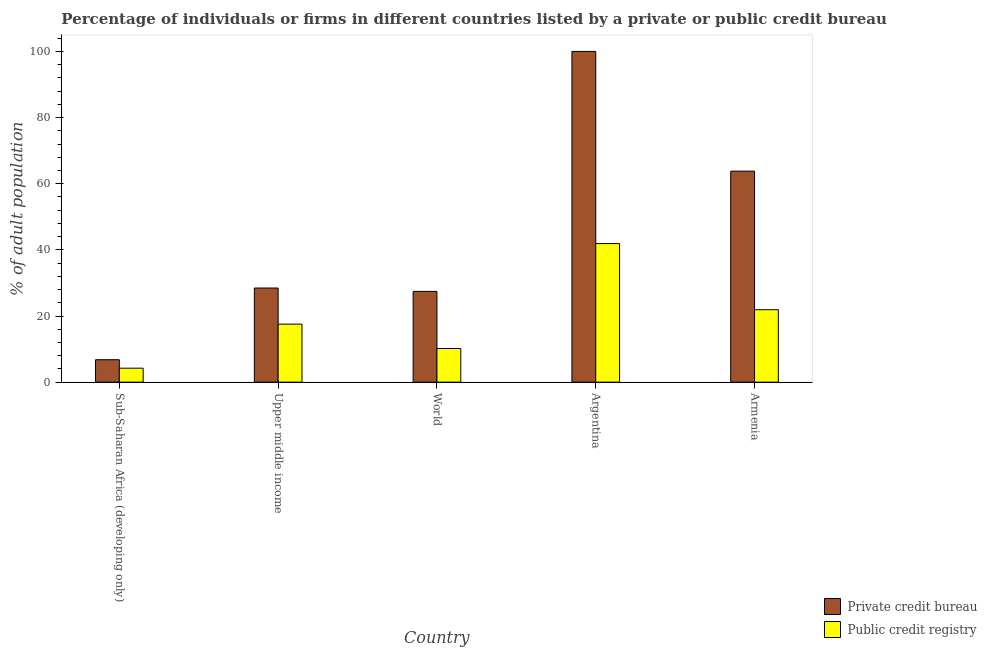How many groups of bars are there?
Provide a short and direct response. 5. Are the number of bars on each tick of the X-axis equal?
Offer a very short reply. Yes. How many bars are there on the 3rd tick from the left?
Make the answer very short. 2. What is the label of the 5th group of bars from the left?
Offer a very short reply. Armenia. In how many cases, is the number of bars for a given country not equal to the number of legend labels?
Keep it short and to the point. 0. What is the percentage of firms listed by private credit bureau in Argentina?
Make the answer very short. 100. Across all countries, what is the maximum percentage of firms listed by private credit bureau?
Give a very brief answer. 100. Across all countries, what is the minimum percentage of firms listed by public credit bureau?
Offer a very short reply. 4.22. In which country was the percentage of firms listed by public credit bureau maximum?
Keep it short and to the point. Argentina. In which country was the percentage of firms listed by public credit bureau minimum?
Provide a short and direct response. Sub-Saharan Africa (developing only). What is the total percentage of firms listed by private credit bureau in the graph?
Your response must be concise. 226.48. What is the difference between the percentage of firms listed by private credit bureau in Upper middle income and that in World?
Your answer should be compact. 1.02. What is the difference between the percentage of firms listed by public credit bureau in Upper middle income and the percentage of firms listed by private credit bureau in Armenia?
Make the answer very short. -46.26. What is the average percentage of firms listed by public credit bureau per country?
Provide a succinct answer. 19.15. What is the difference between the percentage of firms listed by private credit bureau and percentage of firms listed by public credit bureau in Upper middle income?
Keep it short and to the point. 10.92. What is the ratio of the percentage of firms listed by public credit bureau in Argentina to that in Armenia?
Make the answer very short. 1.91. Is the percentage of firms listed by private credit bureau in Armenia less than that in World?
Your answer should be compact. No. What is the difference between the highest and the lowest percentage of firms listed by private credit bureau?
Ensure brevity in your answer.  93.22. In how many countries, is the percentage of firms listed by public credit bureau greater than the average percentage of firms listed by public credit bureau taken over all countries?
Ensure brevity in your answer.  2. What does the 2nd bar from the left in Argentina represents?
Your answer should be very brief. Public credit registry. What does the 2nd bar from the right in Sub-Saharan Africa (developing only) represents?
Your answer should be compact. Private credit bureau. Are all the bars in the graph horizontal?
Your response must be concise. No. How many countries are there in the graph?
Ensure brevity in your answer.  5. Are the values on the major ticks of Y-axis written in scientific E-notation?
Offer a terse response. No. How are the legend labels stacked?
Make the answer very short. Vertical. What is the title of the graph?
Provide a short and direct response. Percentage of individuals or firms in different countries listed by a private or public credit bureau. What is the label or title of the X-axis?
Keep it short and to the point. Country. What is the label or title of the Y-axis?
Give a very brief answer. % of adult population. What is the % of adult population of Private credit bureau in Sub-Saharan Africa (developing only)?
Keep it short and to the point. 6.78. What is the % of adult population in Public credit registry in Sub-Saharan Africa (developing only)?
Offer a terse response. 4.22. What is the % of adult population in Private credit bureau in Upper middle income?
Offer a very short reply. 28.46. What is the % of adult population in Public credit registry in Upper middle income?
Give a very brief answer. 17.54. What is the % of adult population in Private credit bureau in World?
Give a very brief answer. 27.44. What is the % of adult population of Public credit registry in World?
Keep it short and to the point. 10.17. What is the % of adult population in Public credit registry in Argentina?
Offer a terse response. 41.9. What is the % of adult population in Private credit bureau in Armenia?
Offer a terse response. 63.8. What is the % of adult population in Public credit registry in Armenia?
Offer a terse response. 21.9. Across all countries, what is the maximum % of adult population in Private credit bureau?
Make the answer very short. 100. Across all countries, what is the maximum % of adult population of Public credit registry?
Offer a very short reply. 41.9. Across all countries, what is the minimum % of adult population in Private credit bureau?
Ensure brevity in your answer.  6.78. Across all countries, what is the minimum % of adult population of Public credit registry?
Your response must be concise. 4.22. What is the total % of adult population in Private credit bureau in the graph?
Provide a succinct answer. 226.48. What is the total % of adult population in Public credit registry in the graph?
Your answer should be compact. 95.73. What is the difference between the % of adult population in Private credit bureau in Sub-Saharan Africa (developing only) and that in Upper middle income?
Keep it short and to the point. -21.68. What is the difference between the % of adult population of Public credit registry in Sub-Saharan Africa (developing only) and that in Upper middle income?
Your answer should be very brief. -13.32. What is the difference between the % of adult population in Private credit bureau in Sub-Saharan Africa (developing only) and that in World?
Give a very brief answer. -20.66. What is the difference between the % of adult population in Public credit registry in Sub-Saharan Africa (developing only) and that in World?
Make the answer very short. -5.94. What is the difference between the % of adult population of Private credit bureau in Sub-Saharan Africa (developing only) and that in Argentina?
Give a very brief answer. -93.22. What is the difference between the % of adult population of Public credit registry in Sub-Saharan Africa (developing only) and that in Argentina?
Make the answer very short. -37.68. What is the difference between the % of adult population in Private credit bureau in Sub-Saharan Africa (developing only) and that in Armenia?
Your response must be concise. -57.02. What is the difference between the % of adult population in Public credit registry in Sub-Saharan Africa (developing only) and that in Armenia?
Give a very brief answer. -17.68. What is the difference between the % of adult population of Private credit bureau in Upper middle income and that in World?
Offer a terse response. 1.02. What is the difference between the % of adult population of Public credit registry in Upper middle income and that in World?
Offer a terse response. 7.38. What is the difference between the % of adult population in Private credit bureau in Upper middle income and that in Argentina?
Provide a succinct answer. -71.54. What is the difference between the % of adult population in Public credit registry in Upper middle income and that in Argentina?
Ensure brevity in your answer.  -24.36. What is the difference between the % of adult population in Private credit bureau in Upper middle income and that in Armenia?
Your answer should be compact. -35.34. What is the difference between the % of adult population in Public credit registry in Upper middle income and that in Armenia?
Your answer should be very brief. -4.36. What is the difference between the % of adult population of Private credit bureau in World and that in Argentina?
Ensure brevity in your answer.  -72.56. What is the difference between the % of adult population in Public credit registry in World and that in Argentina?
Your answer should be compact. -31.73. What is the difference between the % of adult population of Private credit bureau in World and that in Armenia?
Your answer should be compact. -36.36. What is the difference between the % of adult population of Public credit registry in World and that in Armenia?
Offer a terse response. -11.73. What is the difference between the % of adult population of Private credit bureau in Argentina and that in Armenia?
Offer a very short reply. 36.2. What is the difference between the % of adult population in Private credit bureau in Sub-Saharan Africa (developing only) and the % of adult population in Public credit registry in Upper middle income?
Ensure brevity in your answer.  -10.76. What is the difference between the % of adult population in Private credit bureau in Sub-Saharan Africa (developing only) and the % of adult population in Public credit registry in World?
Make the answer very short. -3.38. What is the difference between the % of adult population in Private credit bureau in Sub-Saharan Africa (developing only) and the % of adult population in Public credit registry in Argentina?
Offer a very short reply. -35.12. What is the difference between the % of adult population of Private credit bureau in Sub-Saharan Africa (developing only) and the % of adult population of Public credit registry in Armenia?
Give a very brief answer. -15.12. What is the difference between the % of adult population in Private credit bureau in Upper middle income and the % of adult population in Public credit registry in World?
Your answer should be very brief. 18.29. What is the difference between the % of adult population in Private credit bureau in Upper middle income and the % of adult population in Public credit registry in Argentina?
Give a very brief answer. -13.44. What is the difference between the % of adult population of Private credit bureau in Upper middle income and the % of adult population of Public credit registry in Armenia?
Your response must be concise. 6.56. What is the difference between the % of adult population in Private credit bureau in World and the % of adult population in Public credit registry in Argentina?
Your answer should be very brief. -14.46. What is the difference between the % of adult population of Private credit bureau in World and the % of adult population of Public credit registry in Armenia?
Your answer should be very brief. 5.54. What is the difference between the % of adult population of Private credit bureau in Argentina and the % of adult population of Public credit registry in Armenia?
Your answer should be compact. 78.1. What is the average % of adult population in Private credit bureau per country?
Provide a short and direct response. 45.3. What is the average % of adult population in Public credit registry per country?
Ensure brevity in your answer.  19.15. What is the difference between the % of adult population in Private credit bureau and % of adult population in Public credit registry in Sub-Saharan Africa (developing only)?
Make the answer very short. 2.56. What is the difference between the % of adult population of Private credit bureau and % of adult population of Public credit registry in Upper middle income?
Offer a terse response. 10.92. What is the difference between the % of adult population in Private credit bureau and % of adult population in Public credit registry in World?
Ensure brevity in your answer.  17.28. What is the difference between the % of adult population in Private credit bureau and % of adult population in Public credit registry in Argentina?
Your answer should be very brief. 58.1. What is the difference between the % of adult population of Private credit bureau and % of adult population of Public credit registry in Armenia?
Offer a very short reply. 41.9. What is the ratio of the % of adult population of Private credit bureau in Sub-Saharan Africa (developing only) to that in Upper middle income?
Keep it short and to the point. 0.24. What is the ratio of the % of adult population in Public credit registry in Sub-Saharan Africa (developing only) to that in Upper middle income?
Keep it short and to the point. 0.24. What is the ratio of the % of adult population of Private credit bureau in Sub-Saharan Africa (developing only) to that in World?
Provide a succinct answer. 0.25. What is the ratio of the % of adult population in Public credit registry in Sub-Saharan Africa (developing only) to that in World?
Your response must be concise. 0.42. What is the ratio of the % of adult population in Private credit bureau in Sub-Saharan Africa (developing only) to that in Argentina?
Give a very brief answer. 0.07. What is the ratio of the % of adult population of Public credit registry in Sub-Saharan Africa (developing only) to that in Argentina?
Ensure brevity in your answer.  0.1. What is the ratio of the % of adult population of Private credit bureau in Sub-Saharan Africa (developing only) to that in Armenia?
Your answer should be very brief. 0.11. What is the ratio of the % of adult population in Public credit registry in Sub-Saharan Africa (developing only) to that in Armenia?
Give a very brief answer. 0.19. What is the ratio of the % of adult population in Private credit bureau in Upper middle income to that in World?
Provide a succinct answer. 1.04. What is the ratio of the % of adult population of Public credit registry in Upper middle income to that in World?
Your answer should be very brief. 1.73. What is the ratio of the % of adult population of Private credit bureau in Upper middle income to that in Argentina?
Keep it short and to the point. 0.28. What is the ratio of the % of adult population in Public credit registry in Upper middle income to that in Argentina?
Provide a short and direct response. 0.42. What is the ratio of the % of adult population in Private credit bureau in Upper middle income to that in Armenia?
Provide a short and direct response. 0.45. What is the ratio of the % of adult population of Public credit registry in Upper middle income to that in Armenia?
Give a very brief answer. 0.8. What is the ratio of the % of adult population of Private credit bureau in World to that in Argentina?
Keep it short and to the point. 0.27. What is the ratio of the % of adult population of Public credit registry in World to that in Argentina?
Your answer should be very brief. 0.24. What is the ratio of the % of adult population of Private credit bureau in World to that in Armenia?
Provide a succinct answer. 0.43. What is the ratio of the % of adult population of Public credit registry in World to that in Armenia?
Ensure brevity in your answer.  0.46. What is the ratio of the % of adult population in Private credit bureau in Argentina to that in Armenia?
Offer a terse response. 1.57. What is the ratio of the % of adult population of Public credit registry in Argentina to that in Armenia?
Keep it short and to the point. 1.91. What is the difference between the highest and the second highest % of adult population of Private credit bureau?
Offer a terse response. 36.2. What is the difference between the highest and the lowest % of adult population of Private credit bureau?
Give a very brief answer. 93.22. What is the difference between the highest and the lowest % of adult population of Public credit registry?
Your answer should be very brief. 37.68. 